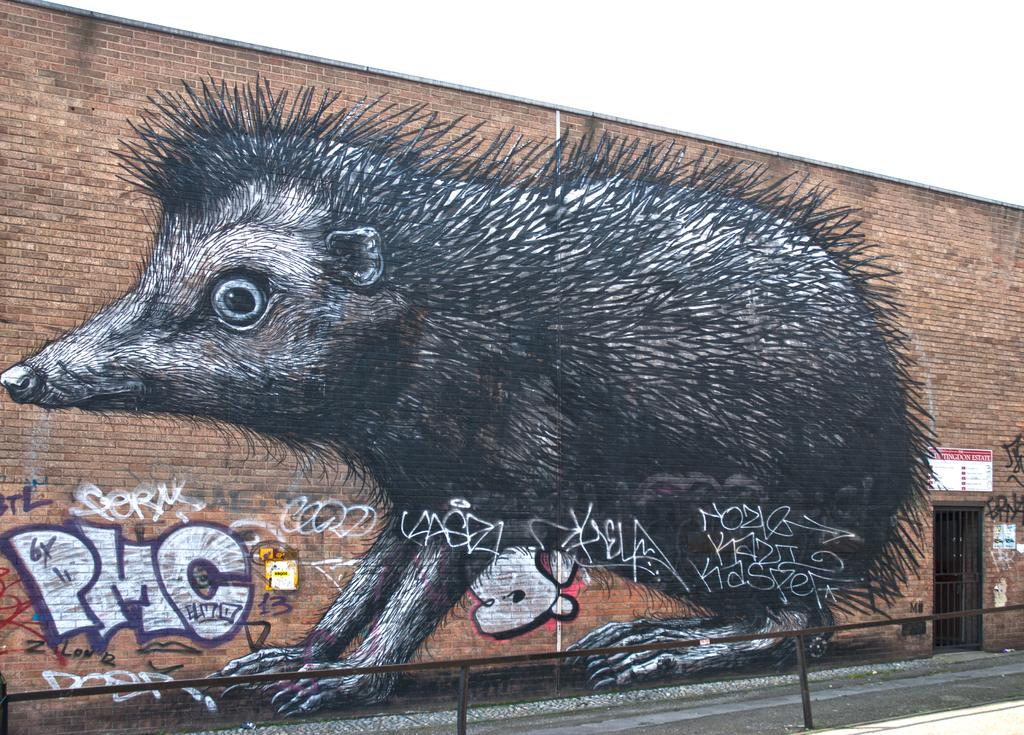What type of barrier can be seen in the image? There is a fence in the image. What other type of barrier is present in the image? There is a brick wall in the image. What is depicted on the brick wall? The brick wall has a large painting of an animal. What can be seen on the right side of the image? There is a grill gate on the right side of the image. What is above the grill gate? There is a board above the grill gate. What is visible at the top of the image? The sky is visible at the top of the image. What type of brain is depicted in the painting on the brick wall? There is no brain depicted in the painting on the brick wall; it features an animal. How does the spoon contribute to the harmony of the image? There is no spoon present in the image, so it cannot contribute to the harmony. 